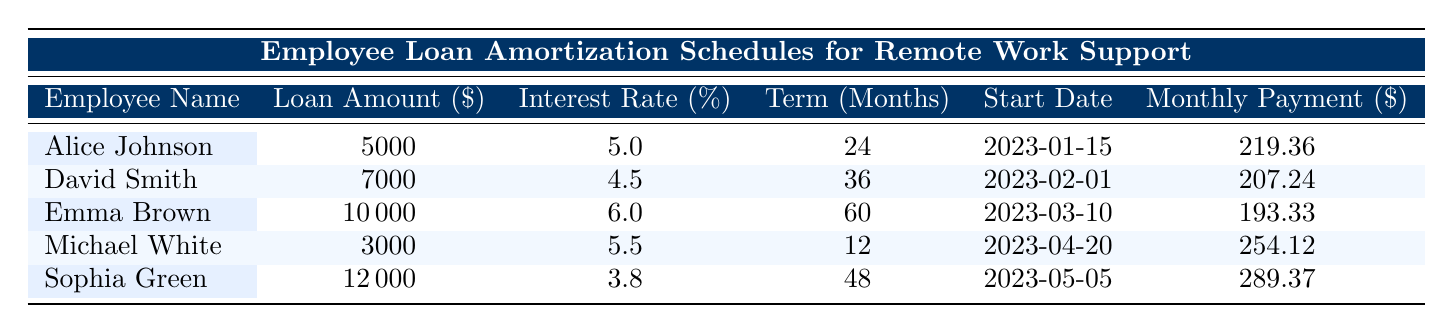What is the loan amount for Emma Brown? To find Emma Brown's loan amount, locate her row in the table. The loan amount listed under her name is $10,000.
Answer: $10,000 Which employee has the lowest interest rate on their loan? Examine the 'Interest Rate (%)' column and identify the lowest value. The lowest interest rate is 3.8%, which corresponds to Sophia Green.
Answer: Sophia Green What is the total loan amount of all employees combined? To find the total loan amount, sum up the values in the 'Loan Amount ($)' column: 5000 + 7000 + 10000 + 3000 + 12000 = 40000.
Answer: $40,000 Is David Smith's monthly payment greater than $200? Looking at David Smith's monthly payment in the 'Monthly Payment ($)' column, it is $207.24, which is indeed greater than $200.
Answer: Yes What is the average term in months for the loans provided? Find the sum of the terms in the 'Term (Months)' column: 24 + 36 + 60 + 12 + 48 = 180. There are 5 loans, so divide by 5 to get the average: 180 / 5 = 36.
Answer: 36 How many employees have a loan term longer than 24 months? Inspect each row to see if the 'Term (Months)' exceeds 24. Emma Brown (60), David Smith (36), and Sophia Green (48) have terms longer than 24 months. This gives us a total of 3 employees.
Answer: 3 What is the difference between the highest and lowest monthly payments? Identify the highest monthly payment (289.37 for Sophia Green) and the lowest (193.33 for Emma Brown). Calculate the difference: 289.37 - 193.33 = 96.04.
Answer: $96.04 Does Alice Johnson have a loan with a term shorter than 24 months? Check Alice Johnson's row under 'Term (Months)'. It shows 24 months, which is not shorter than 24.
Answer: No What is the total interest rate of all loans represented? Add together all the interest rates: 5.0 + 4.5 + 6.0 + 5.5 + 3.8 = 25.8.
Answer: 25.8 